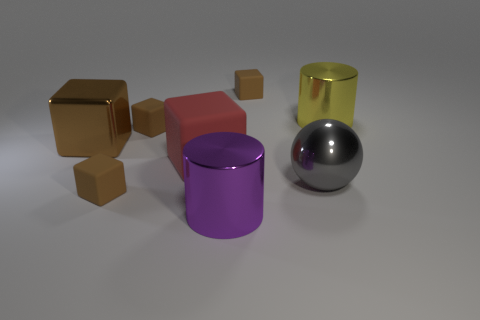There is a shiny cube that is the same size as the gray metal object; what color is it?
Make the answer very short. Brown. How many objects are small brown rubber cubes in front of the red object or blue things?
Your answer should be very brief. 1. What number of other things are there of the same size as the metal block?
Provide a succinct answer. 4. How big is the brown object behind the yellow metallic thing?
Your response must be concise. Small. There is a purple thing that is made of the same material as the yellow object; what is its shape?
Your response must be concise. Cylinder. Is there any other thing of the same color as the metallic block?
Your answer should be compact. Yes. There is a large metallic cylinder that is to the left of the tiny block that is behind the big yellow metallic cylinder; what color is it?
Your answer should be very brief. Purple. How many big things are brown things or gray spheres?
Ensure brevity in your answer.  2. What material is the other object that is the same shape as the large yellow thing?
Ensure brevity in your answer.  Metal. Is there any other thing that has the same material as the large gray thing?
Offer a very short reply. Yes. 